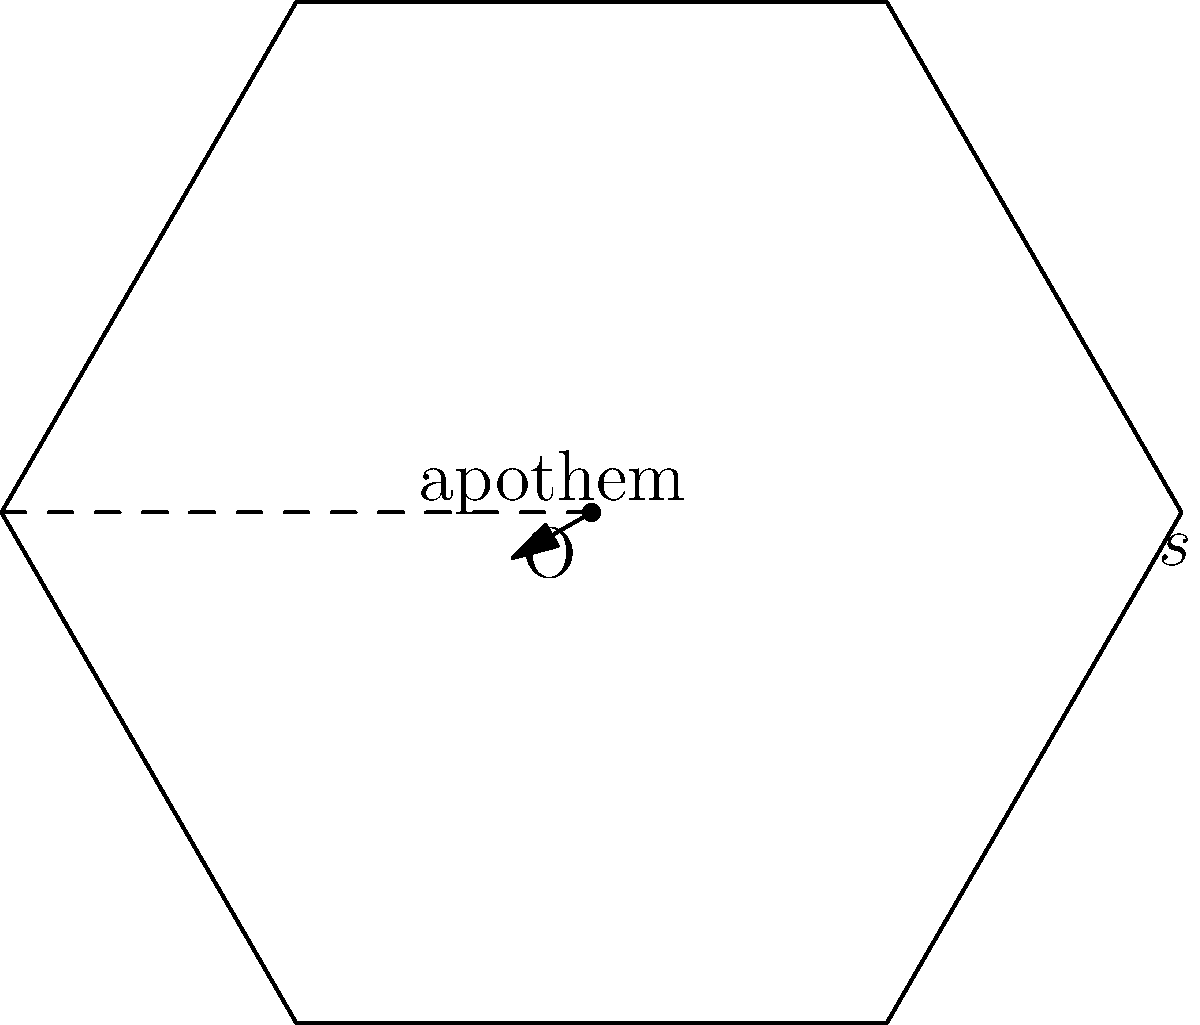As part of a school project on playground safety, you're designing a hexagonal sandbox. The side length of the sandbox is 3 meters, and you've calculated the apothem to be approximately 2.598 meters. What is the area of the sandbox in square meters? Round your answer to two decimal places. Let's approach this step-by-step:

1) The formula for the area of a regular polygon is:

   $$A = \frac{1}{2} \times n \times s \times a$$

   Where:
   $A$ = area
   $n$ = number of sides
   $s$ = side length
   $a$ = apothem

2) We know:
   - The shape is a hexagon, so $n = 6$
   - The side length $s = 3$ meters
   - The apothem $a \approx 2.598$ meters

3) Let's substitute these values into our formula:

   $$A = \frac{1}{2} \times 6 \times 3 \times 2.598$$

4) Now, let's calculate:
   
   $$A = 3 \times 3 \times 2.598 = 23.382$$

5) Rounding to two decimal places:

   $$A \approx 23.38 \text{ square meters}$$
Answer: 23.38 m² 